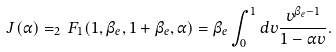<formula> <loc_0><loc_0><loc_500><loc_500>J ( \alpha ) = _ { 2 } \, F _ { 1 } ( 1 , \beta _ { e } , 1 + \beta _ { e } , \alpha ) = \beta _ { e } \int _ { 0 } ^ { 1 } d v \frac { v ^ { \beta _ { e } - 1 } } { 1 - \alpha v } .</formula> 